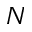Convert formula to latex. <formula><loc_0><loc_0><loc_500><loc_500>N</formula> 